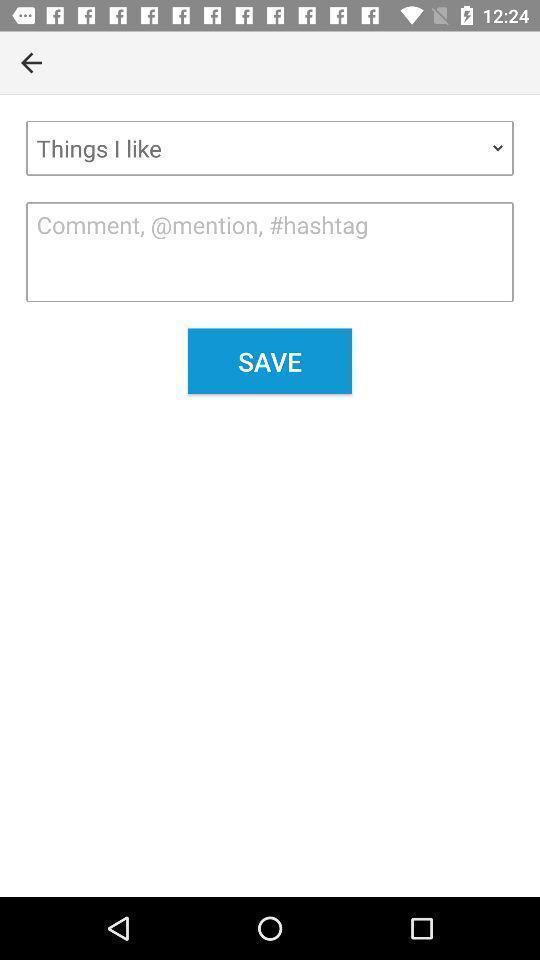Provide a description of this screenshot. Screen display shows dropdown and comments box in shopping app. 